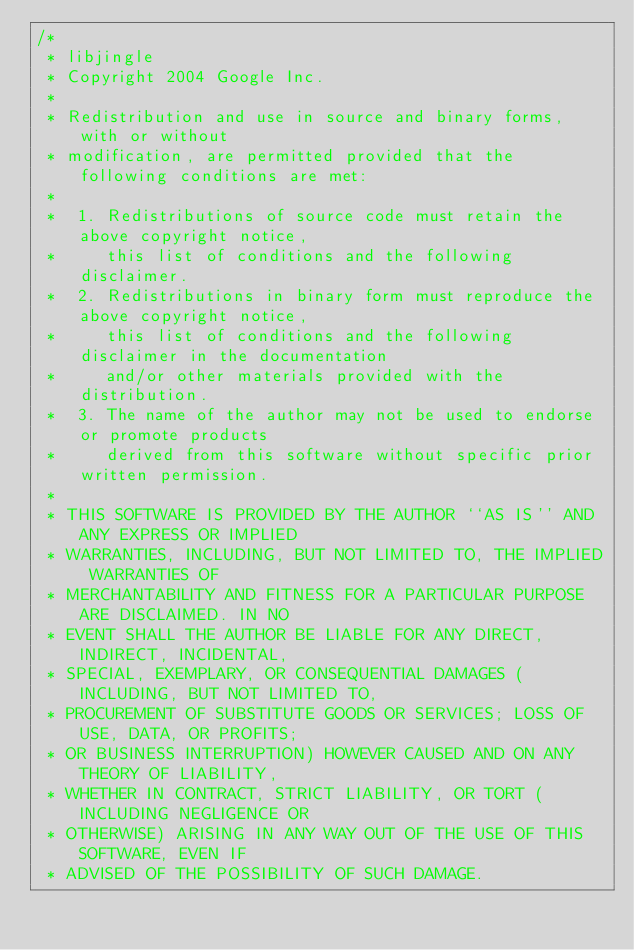Convert code to text. <code><loc_0><loc_0><loc_500><loc_500><_C_>/*
 * libjingle
 * Copyright 2004 Google Inc.
 *
 * Redistribution and use in source and binary forms, with or without
 * modification, are permitted provided that the following conditions are met:
 *
 *  1. Redistributions of source code must retain the above copyright notice,
 *     this list of conditions and the following disclaimer.
 *  2. Redistributions in binary form must reproduce the above copyright notice,
 *     this list of conditions and the following disclaimer in the documentation
 *     and/or other materials provided with the distribution.
 *  3. The name of the author may not be used to endorse or promote products
 *     derived from this software without specific prior written permission.
 *
 * THIS SOFTWARE IS PROVIDED BY THE AUTHOR ``AS IS'' AND ANY EXPRESS OR IMPLIED
 * WARRANTIES, INCLUDING, BUT NOT LIMITED TO, THE IMPLIED WARRANTIES OF
 * MERCHANTABILITY AND FITNESS FOR A PARTICULAR PURPOSE ARE DISCLAIMED. IN NO
 * EVENT SHALL THE AUTHOR BE LIABLE FOR ANY DIRECT, INDIRECT, INCIDENTAL,
 * SPECIAL, EXEMPLARY, OR CONSEQUENTIAL DAMAGES (INCLUDING, BUT NOT LIMITED TO,
 * PROCUREMENT OF SUBSTITUTE GOODS OR SERVICES; LOSS OF USE, DATA, OR PROFITS;
 * OR BUSINESS INTERRUPTION) HOWEVER CAUSED AND ON ANY THEORY OF LIABILITY,
 * WHETHER IN CONTRACT, STRICT LIABILITY, OR TORT (INCLUDING NEGLIGENCE OR
 * OTHERWISE) ARISING IN ANY WAY OUT OF THE USE OF THIS SOFTWARE, EVEN IF
 * ADVISED OF THE POSSIBILITY OF SUCH DAMAGE.</code> 